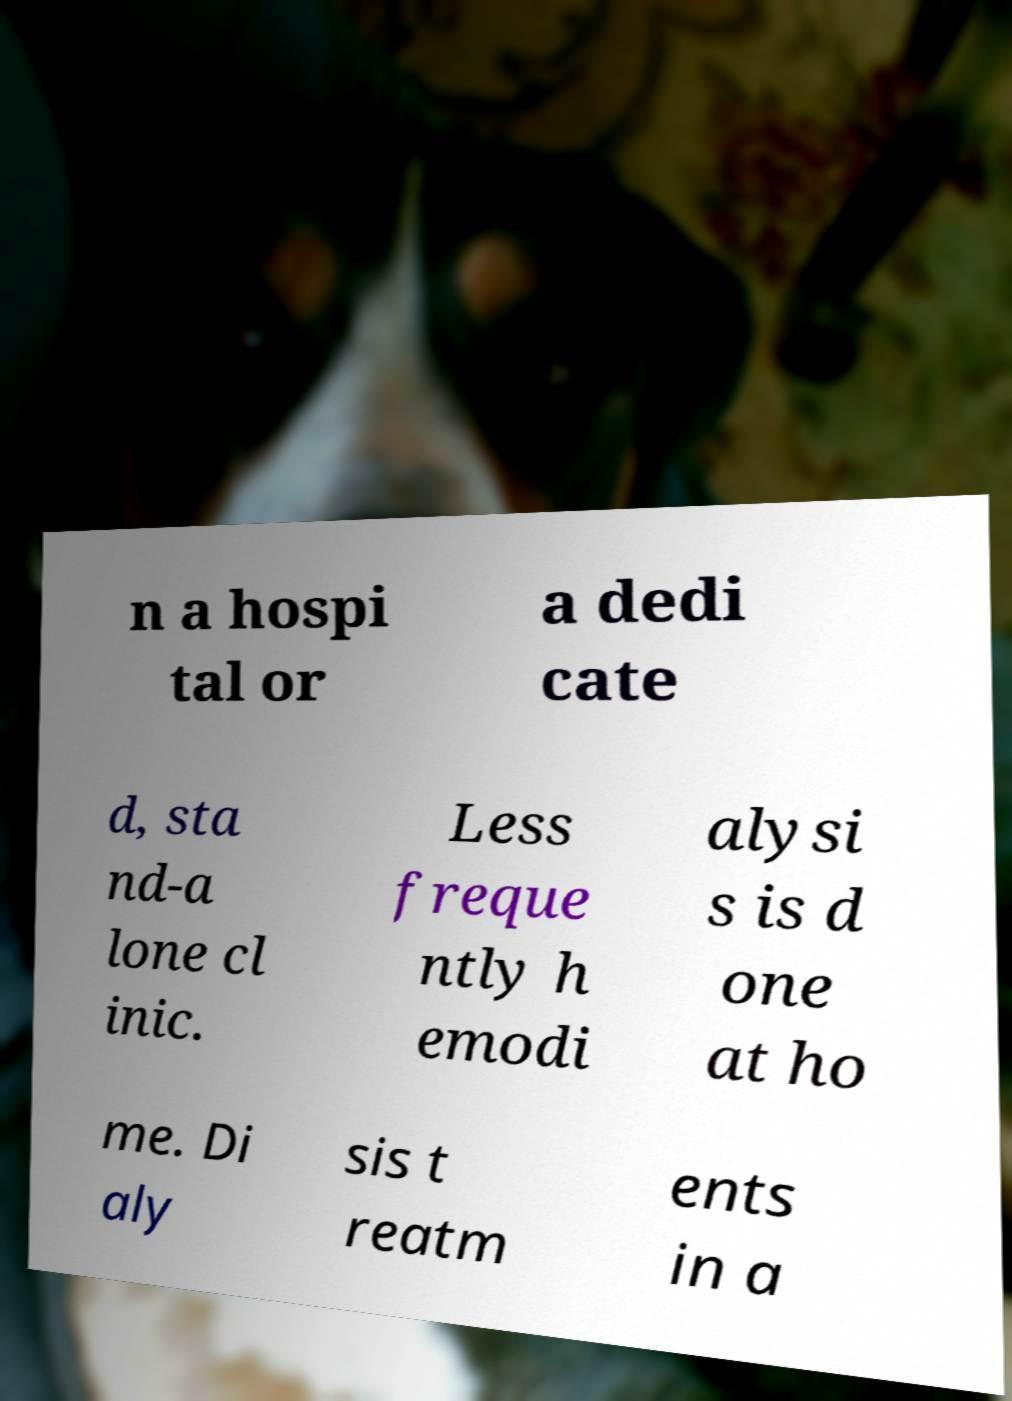Could you extract and type out the text from this image? n a hospi tal or a dedi cate d, sta nd-a lone cl inic. Less freque ntly h emodi alysi s is d one at ho me. Di aly sis t reatm ents in a 